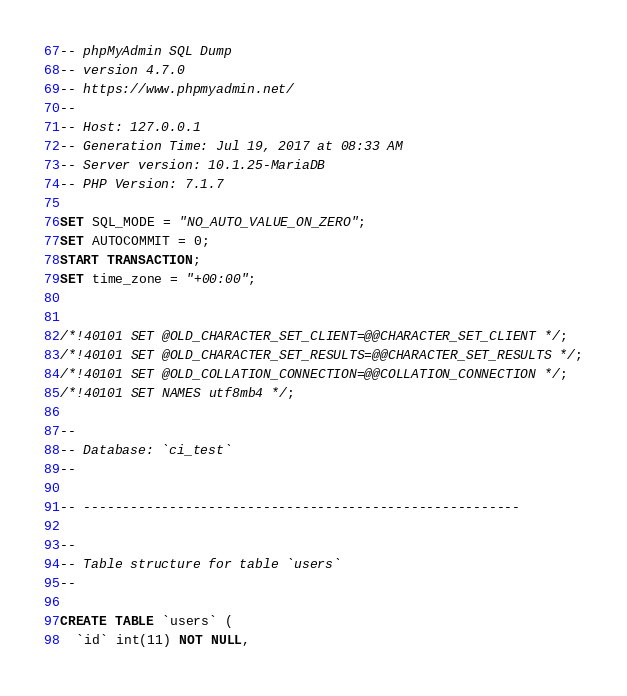Convert code to text. <code><loc_0><loc_0><loc_500><loc_500><_SQL_>-- phpMyAdmin SQL Dump
-- version 4.7.0
-- https://www.phpmyadmin.net/
--
-- Host: 127.0.0.1
-- Generation Time: Jul 19, 2017 at 08:33 AM
-- Server version: 10.1.25-MariaDB
-- PHP Version: 7.1.7

SET SQL_MODE = "NO_AUTO_VALUE_ON_ZERO";
SET AUTOCOMMIT = 0;
START TRANSACTION;
SET time_zone = "+00:00";


/*!40101 SET @OLD_CHARACTER_SET_CLIENT=@@CHARACTER_SET_CLIENT */;
/*!40101 SET @OLD_CHARACTER_SET_RESULTS=@@CHARACTER_SET_RESULTS */;
/*!40101 SET @OLD_COLLATION_CONNECTION=@@COLLATION_CONNECTION */;
/*!40101 SET NAMES utf8mb4 */;

--
-- Database: `ci_test`
--

-- --------------------------------------------------------

--
-- Table structure for table `users`
--

CREATE TABLE `users` (
  `id` int(11) NOT NULL,</code> 